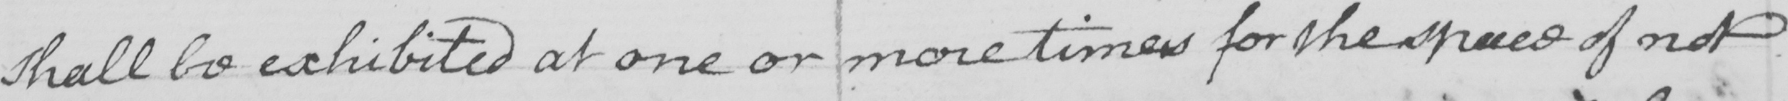What is written in this line of handwriting? shall be exhibited at one or more times for the space of not 